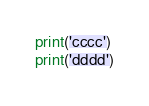Convert code to text. <code><loc_0><loc_0><loc_500><loc_500><_Python_>print('cccc')
print('dddd')
</code> 